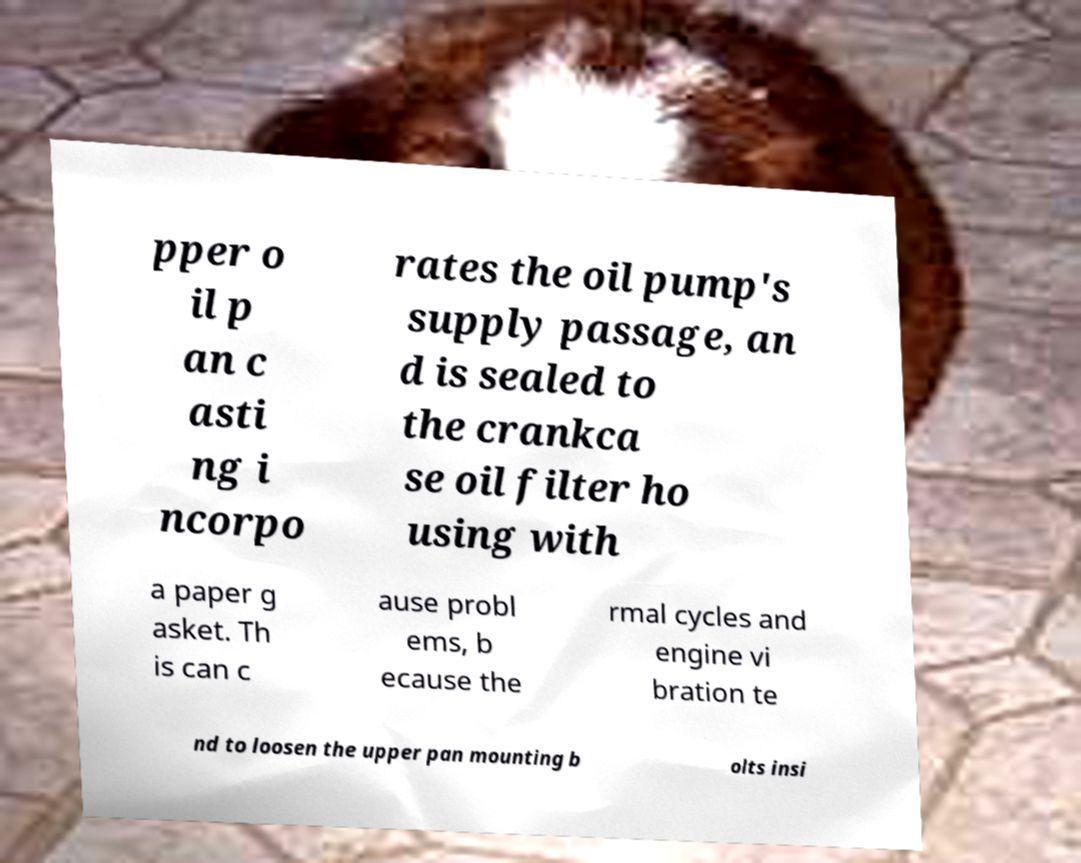Could you assist in decoding the text presented in this image and type it out clearly? pper o il p an c asti ng i ncorpo rates the oil pump's supply passage, an d is sealed to the crankca se oil filter ho using with a paper g asket. Th is can c ause probl ems, b ecause the rmal cycles and engine vi bration te nd to loosen the upper pan mounting b olts insi 